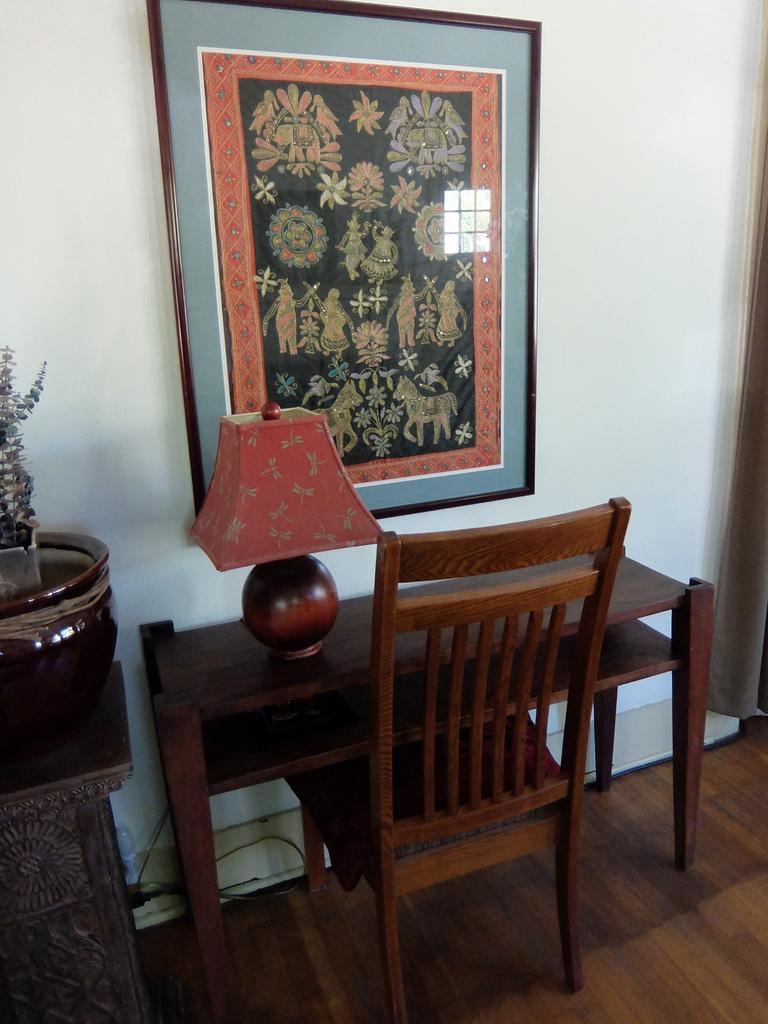What type of furniture is present in the image? There is a table and a chair in the image. What is the purpose of the object on the table? The lamp on the table provides light. Where is the flower pot located in the image? The flower pot is on the left side of the image. What is hanging on the wall in the image? There is a photo frame on the wall in the image. What type of berry is growing on the veins of the chair in the image? There are no berries or veins present on the chair in the image. 